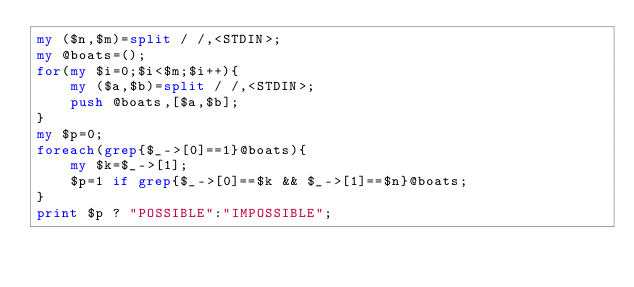<code> <loc_0><loc_0><loc_500><loc_500><_Perl_>my ($n,$m)=split / /,<STDIN>;
my @boats=();
for(my $i=0;$i<$m;$i++){
    my ($a,$b)=split / /,<STDIN>;
    push @boats,[$a,$b];
}
my $p=0;
foreach(grep{$_->[0]==1}@boats){
    my $k=$_->[1];
    $p=1 if grep{$_->[0]==$k && $_->[1]==$n}@boats;
}
print $p ? "POSSIBLE":"IMPOSSIBLE";</code> 